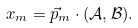<formula> <loc_0><loc_0><loc_500><loc_500>x _ { m } = \vec { p } _ { m } \cdot ( \mathcal { A } , \mathcal { B } ) .</formula> 